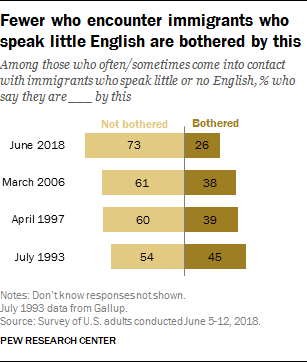Highlight a few significant elements in this photo. Based on the responses to the prompt "What is the average of 'bothered' responses? (in percent)? 0.37," it can be concluded that the average response is 0.37. 